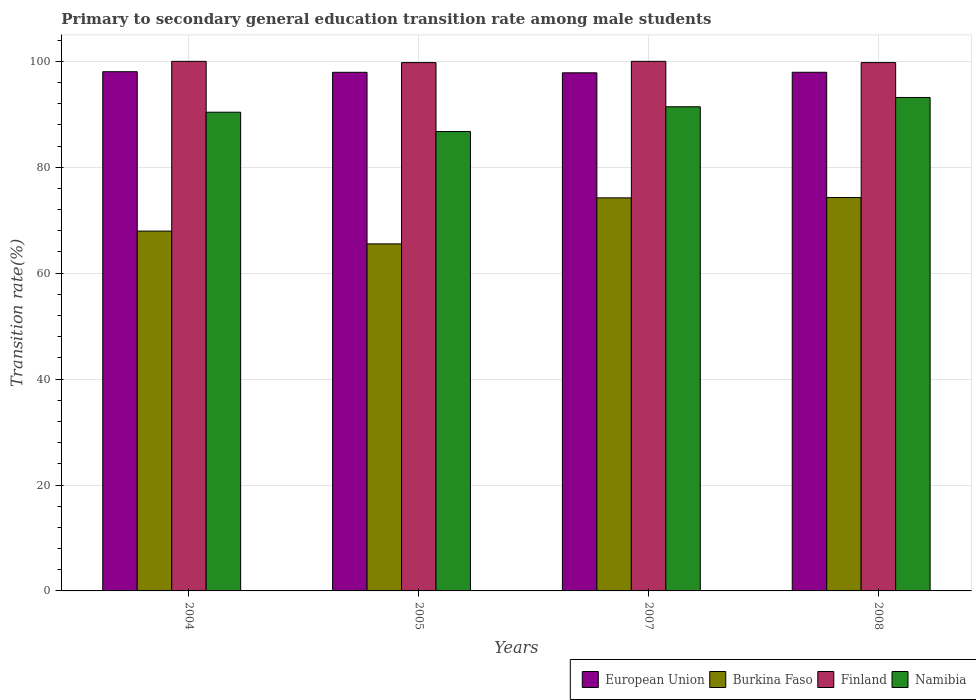Are the number of bars per tick equal to the number of legend labels?
Provide a short and direct response. Yes. Are the number of bars on each tick of the X-axis equal?
Your response must be concise. Yes. How many bars are there on the 1st tick from the left?
Give a very brief answer. 4. What is the label of the 1st group of bars from the left?
Your answer should be very brief. 2004. What is the transition rate in Finland in 2004?
Provide a succinct answer. 100. Across all years, what is the minimum transition rate in Burkina Faso?
Provide a short and direct response. 65.53. In which year was the transition rate in Finland minimum?
Your answer should be compact. 2008. What is the total transition rate in Burkina Faso in the graph?
Offer a very short reply. 281.99. What is the difference between the transition rate in Burkina Faso in 2007 and that in 2008?
Provide a short and direct response. -0.06. What is the difference between the transition rate in Burkina Faso in 2008 and the transition rate in European Union in 2005?
Your answer should be very brief. -23.65. What is the average transition rate in Burkina Faso per year?
Provide a succinct answer. 70.5. In the year 2007, what is the difference between the transition rate in Burkina Faso and transition rate in European Union?
Provide a short and direct response. -23.61. In how many years, is the transition rate in Burkina Faso greater than 20 %?
Ensure brevity in your answer.  4. What is the ratio of the transition rate in Burkina Faso in 2004 to that in 2008?
Make the answer very short. 0.91. Is the difference between the transition rate in Burkina Faso in 2004 and 2005 greater than the difference between the transition rate in European Union in 2004 and 2005?
Offer a terse response. Yes. What is the difference between the highest and the second highest transition rate in Burkina Faso?
Offer a very short reply. 0.06. What is the difference between the highest and the lowest transition rate in Burkina Faso?
Provide a short and direct response. 8.75. In how many years, is the transition rate in Finland greater than the average transition rate in Finland taken over all years?
Your answer should be very brief. 2. Is it the case that in every year, the sum of the transition rate in European Union and transition rate in Namibia is greater than the sum of transition rate in Finland and transition rate in Burkina Faso?
Ensure brevity in your answer.  No. What does the 2nd bar from the left in 2005 represents?
Your answer should be compact. Burkina Faso. Is it the case that in every year, the sum of the transition rate in Burkina Faso and transition rate in Finland is greater than the transition rate in European Union?
Offer a terse response. Yes. Are all the bars in the graph horizontal?
Your answer should be compact. No. What is the difference between two consecutive major ticks on the Y-axis?
Make the answer very short. 20. What is the title of the graph?
Make the answer very short. Primary to secondary general education transition rate among male students. What is the label or title of the X-axis?
Give a very brief answer. Years. What is the label or title of the Y-axis?
Offer a very short reply. Transition rate(%). What is the Transition rate(%) in European Union in 2004?
Give a very brief answer. 98.04. What is the Transition rate(%) of Burkina Faso in 2004?
Offer a very short reply. 67.95. What is the Transition rate(%) in Finland in 2004?
Give a very brief answer. 100. What is the Transition rate(%) in Namibia in 2004?
Give a very brief answer. 90.39. What is the Transition rate(%) of European Union in 2005?
Make the answer very short. 97.93. What is the Transition rate(%) in Burkina Faso in 2005?
Your response must be concise. 65.53. What is the Transition rate(%) in Finland in 2005?
Give a very brief answer. 99.77. What is the Transition rate(%) in Namibia in 2005?
Give a very brief answer. 86.75. What is the Transition rate(%) in European Union in 2007?
Offer a terse response. 97.84. What is the Transition rate(%) in Burkina Faso in 2007?
Offer a very short reply. 74.22. What is the Transition rate(%) in Namibia in 2007?
Ensure brevity in your answer.  91.43. What is the Transition rate(%) of European Union in 2008?
Your answer should be compact. 97.94. What is the Transition rate(%) in Burkina Faso in 2008?
Your response must be concise. 74.28. What is the Transition rate(%) in Finland in 2008?
Your response must be concise. 99.76. What is the Transition rate(%) in Namibia in 2008?
Provide a short and direct response. 93.18. Across all years, what is the maximum Transition rate(%) of European Union?
Give a very brief answer. 98.04. Across all years, what is the maximum Transition rate(%) of Burkina Faso?
Provide a short and direct response. 74.28. Across all years, what is the maximum Transition rate(%) in Finland?
Your answer should be very brief. 100. Across all years, what is the maximum Transition rate(%) of Namibia?
Make the answer very short. 93.18. Across all years, what is the minimum Transition rate(%) in European Union?
Your answer should be very brief. 97.84. Across all years, what is the minimum Transition rate(%) of Burkina Faso?
Offer a very short reply. 65.53. Across all years, what is the minimum Transition rate(%) of Finland?
Offer a terse response. 99.76. Across all years, what is the minimum Transition rate(%) in Namibia?
Make the answer very short. 86.75. What is the total Transition rate(%) in European Union in the graph?
Provide a short and direct response. 391.75. What is the total Transition rate(%) in Burkina Faso in the graph?
Your response must be concise. 281.99. What is the total Transition rate(%) of Finland in the graph?
Your answer should be compact. 399.53. What is the total Transition rate(%) of Namibia in the graph?
Provide a succinct answer. 361.75. What is the difference between the Transition rate(%) in European Union in 2004 and that in 2005?
Give a very brief answer. 0.11. What is the difference between the Transition rate(%) in Burkina Faso in 2004 and that in 2005?
Your answer should be compact. 2.42. What is the difference between the Transition rate(%) of Finland in 2004 and that in 2005?
Make the answer very short. 0.23. What is the difference between the Transition rate(%) of Namibia in 2004 and that in 2005?
Offer a terse response. 3.65. What is the difference between the Transition rate(%) in European Union in 2004 and that in 2007?
Make the answer very short. 0.21. What is the difference between the Transition rate(%) of Burkina Faso in 2004 and that in 2007?
Ensure brevity in your answer.  -6.27. What is the difference between the Transition rate(%) in Namibia in 2004 and that in 2007?
Your response must be concise. -1.03. What is the difference between the Transition rate(%) of European Union in 2004 and that in 2008?
Offer a very short reply. 0.1. What is the difference between the Transition rate(%) of Burkina Faso in 2004 and that in 2008?
Make the answer very short. -6.34. What is the difference between the Transition rate(%) in Finland in 2004 and that in 2008?
Provide a succinct answer. 0.24. What is the difference between the Transition rate(%) of Namibia in 2004 and that in 2008?
Offer a very short reply. -2.78. What is the difference between the Transition rate(%) of European Union in 2005 and that in 2007?
Your answer should be very brief. 0.1. What is the difference between the Transition rate(%) of Burkina Faso in 2005 and that in 2007?
Keep it short and to the point. -8.69. What is the difference between the Transition rate(%) of Finland in 2005 and that in 2007?
Give a very brief answer. -0.23. What is the difference between the Transition rate(%) of Namibia in 2005 and that in 2007?
Keep it short and to the point. -4.68. What is the difference between the Transition rate(%) of European Union in 2005 and that in 2008?
Offer a very short reply. -0.01. What is the difference between the Transition rate(%) in Burkina Faso in 2005 and that in 2008?
Your response must be concise. -8.75. What is the difference between the Transition rate(%) of Finland in 2005 and that in 2008?
Give a very brief answer. 0. What is the difference between the Transition rate(%) of Namibia in 2005 and that in 2008?
Provide a short and direct response. -6.43. What is the difference between the Transition rate(%) of European Union in 2007 and that in 2008?
Your response must be concise. -0.1. What is the difference between the Transition rate(%) in Burkina Faso in 2007 and that in 2008?
Make the answer very short. -0.06. What is the difference between the Transition rate(%) of Finland in 2007 and that in 2008?
Give a very brief answer. 0.24. What is the difference between the Transition rate(%) in Namibia in 2007 and that in 2008?
Provide a succinct answer. -1.75. What is the difference between the Transition rate(%) in European Union in 2004 and the Transition rate(%) in Burkina Faso in 2005?
Offer a terse response. 32.51. What is the difference between the Transition rate(%) in European Union in 2004 and the Transition rate(%) in Finland in 2005?
Your response must be concise. -1.72. What is the difference between the Transition rate(%) in European Union in 2004 and the Transition rate(%) in Namibia in 2005?
Your answer should be very brief. 11.29. What is the difference between the Transition rate(%) of Burkina Faso in 2004 and the Transition rate(%) of Finland in 2005?
Your answer should be compact. -31.82. What is the difference between the Transition rate(%) of Burkina Faso in 2004 and the Transition rate(%) of Namibia in 2005?
Ensure brevity in your answer.  -18.8. What is the difference between the Transition rate(%) in Finland in 2004 and the Transition rate(%) in Namibia in 2005?
Provide a succinct answer. 13.25. What is the difference between the Transition rate(%) in European Union in 2004 and the Transition rate(%) in Burkina Faso in 2007?
Ensure brevity in your answer.  23.82. What is the difference between the Transition rate(%) in European Union in 2004 and the Transition rate(%) in Finland in 2007?
Your answer should be very brief. -1.96. What is the difference between the Transition rate(%) in European Union in 2004 and the Transition rate(%) in Namibia in 2007?
Provide a succinct answer. 6.62. What is the difference between the Transition rate(%) in Burkina Faso in 2004 and the Transition rate(%) in Finland in 2007?
Provide a short and direct response. -32.05. What is the difference between the Transition rate(%) of Burkina Faso in 2004 and the Transition rate(%) of Namibia in 2007?
Provide a succinct answer. -23.48. What is the difference between the Transition rate(%) in Finland in 2004 and the Transition rate(%) in Namibia in 2007?
Your answer should be compact. 8.57. What is the difference between the Transition rate(%) in European Union in 2004 and the Transition rate(%) in Burkina Faso in 2008?
Ensure brevity in your answer.  23.76. What is the difference between the Transition rate(%) in European Union in 2004 and the Transition rate(%) in Finland in 2008?
Offer a terse response. -1.72. What is the difference between the Transition rate(%) of European Union in 2004 and the Transition rate(%) of Namibia in 2008?
Provide a succinct answer. 4.86. What is the difference between the Transition rate(%) of Burkina Faso in 2004 and the Transition rate(%) of Finland in 2008?
Ensure brevity in your answer.  -31.82. What is the difference between the Transition rate(%) in Burkina Faso in 2004 and the Transition rate(%) in Namibia in 2008?
Provide a short and direct response. -25.23. What is the difference between the Transition rate(%) in Finland in 2004 and the Transition rate(%) in Namibia in 2008?
Your response must be concise. 6.82. What is the difference between the Transition rate(%) in European Union in 2005 and the Transition rate(%) in Burkina Faso in 2007?
Your answer should be very brief. 23.71. What is the difference between the Transition rate(%) of European Union in 2005 and the Transition rate(%) of Finland in 2007?
Your response must be concise. -2.07. What is the difference between the Transition rate(%) in European Union in 2005 and the Transition rate(%) in Namibia in 2007?
Your answer should be very brief. 6.51. What is the difference between the Transition rate(%) in Burkina Faso in 2005 and the Transition rate(%) in Finland in 2007?
Give a very brief answer. -34.47. What is the difference between the Transition rate(%) in Burkina Faso in 2005 and the Transition rate(%) in Namibia in 2007?
Ensure brevity in your answer.  -25.89. What is the difference between the Transition rate(%) in Finland in 2005 and the Transition rate(%) in Namibia in 2007?
Your response must be concise. 8.34. What is the difference between the Transition rate(%) of European Union in 2005 and the Transition rate(%) of Burkina Faso in 2008?
Offer a terse response. 23.65. What is the difference between the Transition rate(%) of European Union in 2005 and the Transition rate(%) of Finland in 2008?
Your answer should be very brief. -1.83. What is the difference between the Transition rate(%) in European Union in 2005 and the Transition rate(%) in Namibia in 2008?
Your answer should be very brief. 4.75. What is the difference between the Transition rate(%) in Burkina Faso in 2005 and the Transition rate(%) in Finland in 2008?
Your answer should be compact. -34.23. What is the difference between the Transition rate(%) of Burkina Faso in 2005 and the Transition rate(%) of Namibia in 2008?
Provide a short and direct response. -27.65. What is the difference between the Transition rate(%) of Finland in 2005 and the Transition rate(%) of Namibia in 2008?
Provide a succinct answer. 6.59. What is the difference between the Transition rate(%) in European Union in 2007 and the Transition rate(%) in Burkina Faso in 2008?
Ensure brevity in your answer.  23.55. What is the difference between the Transition rate(%) of European Union in 2007 and the Transition rate(%) of Finland in 2008?
Make the answer very short. -1.93. What is the difference between the Transition rate(%) of European Union in 2007 and the Transition rate(%) of Namibia in 2008?
Provide a succinct answer. 4.66. What is the difference between the Transition rate(%) of Burkina Faso in 2007 and the Transition rate(%) of Finland in 2008?
Make the answer very short. -25.54. What is the difference between the Transition rate(%) of Burkina Faso in 2007 and the Transition rate(%) of Namibia in 2008?
Your answer should be very brief. -18.96. What is the difference between the Transition rate(%) of Finland in 2007 and the Transition rate(%) of Namibia in 2008?
Give a very brief answer. 6.82. What is the average Transition rate(%) of European Union per year?
Your answer should be compact. 97.94. What is the average Transition rate(%) of Burkina Faso per year?
Offer a terse response. 70.5. What is the average Transition rate(%) in Finland per year?
Your answer should be very brief. 99.88. What is the average Transition rate(%) of Namibia per year?
Give a very brief answer. 90.44. In the year 2004, what is the difference between the Transition rate(%) in European Union and Transition rate(%) in Burkina Faso?
Make the answer very short. 30.09. In the year 2004, what is the difference between the Transition rate(%) in European Union and Transition rate(%) in Finland?
Provide a short and direct response. -1.96. In the year 2004, what is the difference between the Transition rate(%) of European Union and Transition rate(%) of Namibia?
Your response must be concise. 7.65. In the year 2004, what is the difference between the Transition rate(%) of Burkina Faso and Transition rate(%) of Finland?
Give a very brief answer. -32.05. In the year 2004, what is the difference between the Transition rate(%) of Burkina Faso and Transition rate(%) of Namibia?
Provide a succinct answer. -22.45. In the year 2004, what is the difference between the Transition rate(%) in Finland and Transition rate(%) in Namibia?
Give a very brief answer. 9.61. In the year 2005, what is the difference between the Transition rate(%) in European Union and Transition rate(%) in Burkina Faso?
Provide a succinct answer. 32.4. In the year 2005, what is the difference between the Transition rate(%) of European Union and Transition rate(%) of Finland?
Your response must be concise. -1.83. In the year 2005, what is the difference between the Transition rate(%) of European Union and Transition rate(%) of Namibia?
Your response must be concise. 11.18. In the year 2005, what is the difference between the Transition rate(%) in Burkina Faso and Transition rate(%) in Finland?
Give a very brief answer. -34.23. In the year 2005, what is the difference between the Transition rate(%) of Burkina Faso and Transition rate(%) of Namibia?
Give a very brief answer. -21.22. In the year 2005, what is the difference between the Transition rate(%) of Finland and Transition rate(%) of Namibia?
Keep it short and to the point. 13.02. In the year 2007, what is the difference between the Transition rate(%) of European Union and Transition rate(%) of Burkina Faso?
Your response must be concise. 23.61. In the year 2007, what is the difference between the Transition rate(%) in European Union and Transition rate(%) in Finland?
Give a very brief answer. -2.16. In the year 2007, what is the difference between the Transition rate(%) of European Union and Transition rate(%) of Namibia?
Your answer should be compact. 6.41. In the year 2007, what is the difference between the Transition rate(%) of Burkina Faso and Transition rate(%) of Finland?
Give a very brief answer. -25.78. In the year 2007, what is the difference between the Transition rate(%) of Burkina Faso and Transition rate(%) of Namibia?
Make the answer very short. -17.2. In the year 2007, what is the difference between the Transition rate(%) in Finland and Transition rate(%) in Namibia?
Ensure brevity in your answer.  8.57. In the year 2008, what is the difference between the Transition rate(%) in European Union and Transition rate(%) in Burkina Faso?
Offer a very short reply. 23.65. In the year 2008, what is the difference between the Transition rate(%) in European Union and Transition rate(%) in Finland?
Offer a very short reply. -1.82. In the year 2008, what is the difference between the Transition rate(%) in European Union and Transition rate(%) in Namibia?
Provide a short and direct response. 4.76. In the year 2008, what is the difference between the Transition rate(%) of Burkina Faso and Transition rate(%) of Finland?
Keep it short and to the point. -25.48. In the year 2008, what is the difference between the Transition rate(%) of Burkina Faso and Transition rate(%) of Namibia?
Make the answer very short. -18.89. In the year 2008, what is the difference between the Transition rate(%) of Finland and Transition rate(%) of Namibia?
Keep it short and to the point. 6.58. What is the ratio of the Transition rate(%) in European Union in 2004 to that in 2005?
Give a very brief answer. 1. What is the ratio of the Transition rate(%) of Burkina Faso in 2004 to that in 2005?
Offer a very short reply. 1.04. What is the ratio of the Transition rate(%) of Finland in 2004 to that in 2005?
Your answer should be very brief. 1. What is the ratio of the Transition rate(%) of Namibia in 2004 to that in 2005?
Keep it short and to the point. 1.04. What is the ratio of the Transition rate(%) in Burkina Faso in 2004 to that in 2007?
Provide a succinct answer. 0.92. What is the ratio of the Transition rate(%) in Namibia in 2004 to that in 2007?
Your answer should be very brief. 0.99. What is the ratio of the Transition rate(%) of Burkina Faso in 2004 to that in 2008?
Offer a terse response. 0.91. What is the ratio of the Transition rate(%) of Namibia in 2004 to that in 2008?
Offer a terse response. 0.97. What is the ratio of the Transition rate(%) of Burkina Faso in 2005 to that in 2007?
Provide a short and direct response. 0.88. What is the ratio of the Transition rate(%) of Finland in 2005 to that in 2007?
Your answer should be compact. 1. What is the ratio of the Transition rate(%) in Namibia in 2005 to that in 2007?
Offer a very short reply. 0.95. What is the ratio of the Transition rate(%) in Burkina Faso in 2005 to that in 2008?
Give a very brief answer. 0.88. What is the ratio of the Transition rate(%) of European Union in 2007 to that in 2008?
Provide a short and direct response. 1. What is the ratio of the Transition rate(%) of Burkina Faso in 2007 to that in 2008?
Offer a very short reply. 1. What is the ratio of the Transition rate(%) in Finland in 2007 to that in 2008?
Provide a short and direct response. 1. What is the ratio of the Transition rate(%) of Namibia in 2007 to that in 2008?
Ensure brevity in your answer.  0.98. What is the difference between the highest and the second highest Transition rate(%) of European Union?
Offer a terse response. 0.1. What is the difference between the highest and the second highest Transition rate(%) in Burkina Faso?
Give a very brief answer. 0.06. What is the difference between the highest and the second highest Transition rate(%) in Finland?
Offer a terse response. 0. What is the difference between the highest and the second highest Transition rate(%) in Namibia?
Your answer should be compact. 1.75. What is the difference between the highest and the lowest Transition rate(%) in European Union?
Offer a terse response. 0.21. What is the difference between the highest and the lowest Transition rate(%) in Burkina Faso?
Provide a succinct answer. 8.75. What is the difference between the highest and the lowest Transition rate(%) in Finland?
Provide a succinct answer. 0.24. What is the difference between the highest and the lowest Transition rate(%) of Namibia?
Your response must be concise. 6.43. 